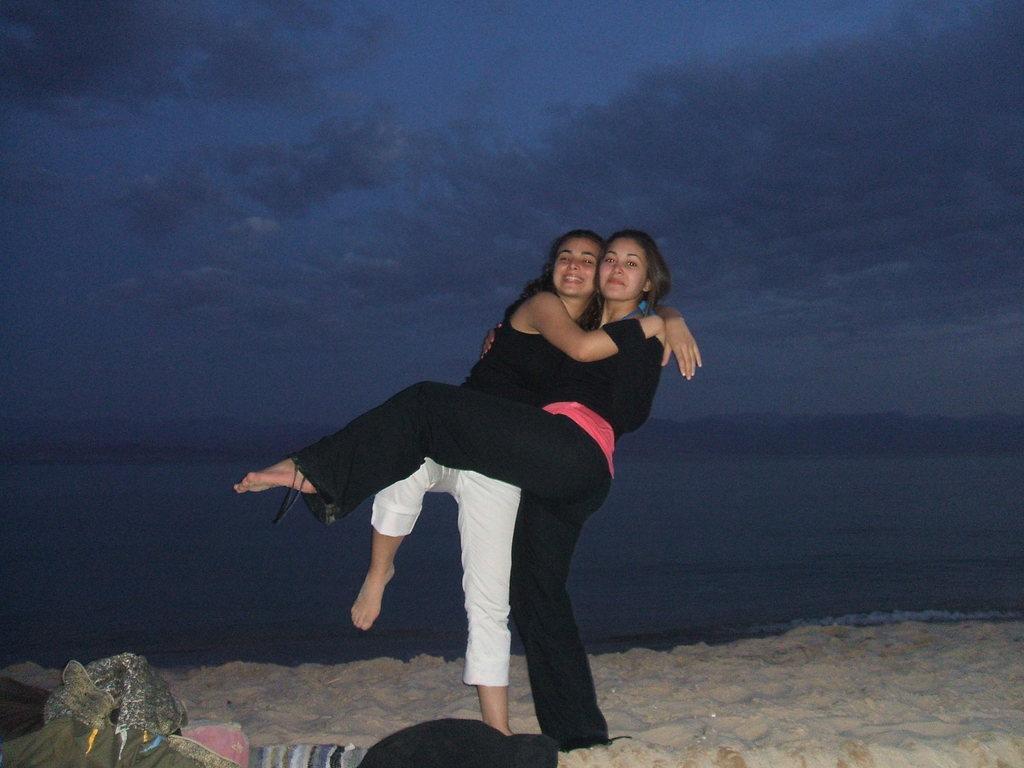Describe this image in one or two sentences. Here we can see two women on the sand. This is water. In the background we can see sky. 